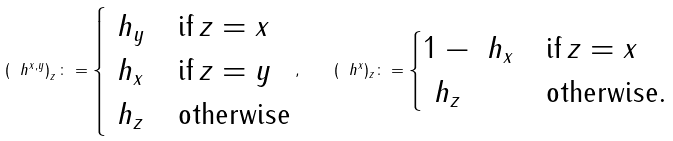<formula> <loc_0><loc_0><loc_500><loc_500>\left ( \ h ^ { x , y } \right ) _ { z } \colon = \begin{cases} \ h _ { y } & \text {if} \, z = x \\ \ h _ { x } & \text {if} \, z = y \\ \ h _ { z } & \text {otherwise} \end{cases} , \quad ( \ h ^ { x } ) _ { z } \colon = \begin{cases} 1 - \ h _ { x } & \text {if} \, z = x \\ \ h _ { z } & \text {otherwise} . \end{cases}</formula> 